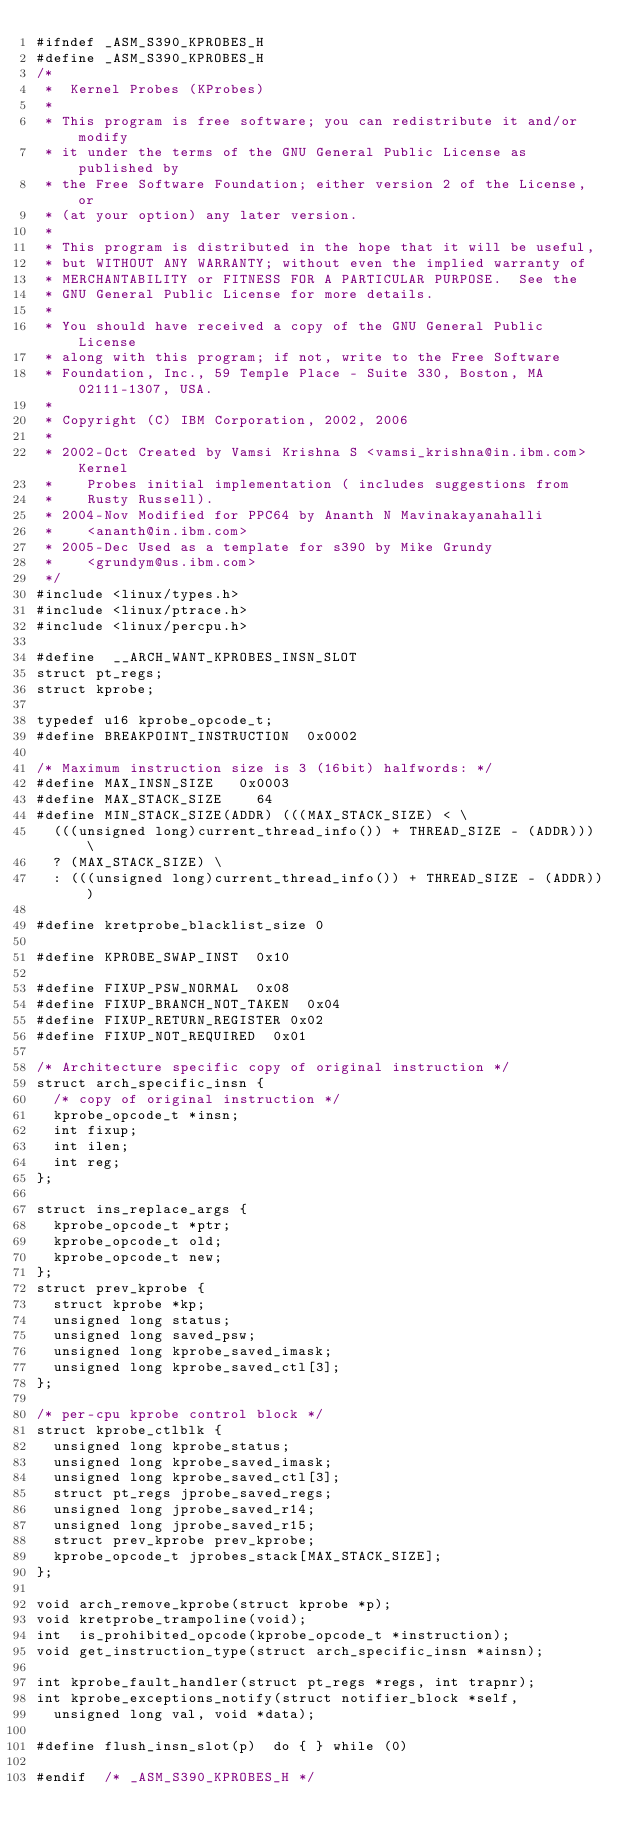<code> <loc_0><loc_0><loc_500><loc_500><_C_>#ifndef _ASM_S390_KPROBES_H
#define _ASM_S390_KPROBES_H
/*
 *  Kernel Probes (KProbes)
 *
 * This program is free software; you can redistribute it and/or modify
 * it under the terms of the GNU General Public License as published by
 * the Free Software Foundation; either version 2 of the License, or
 * (at your option) any later version.
 *
 * This program is distributed in the hope that it will be useful,
 * but WITHOUT ANY WARRANTY; without even the implied warranty of
 * MERCHANTABILITY or FITNESS FOR A PARTICULAR PURPOSE.  See the
 * GNU General Public License for more details.
 *
 * You should have received a copy of the GNU General Public License
 * along with this program; if not, write to the Free Software
 * Foundation, Inc., 59 Temple Place - Suite 330, Boston, MA 02111-1307, USA.
 *
 * Copyright (C) IBM Corporation, 2002, 2006
 *
 * 2002-Oct	Created by Vamsi Krishna S <vamsi_krishna@in.ibm.com> Kernel
 *		Probes initial implementation ( includes suggestions from
 *		Rusty Russell).
 * 2004-Nov	Modified for PPC64 by Ananth N Mavinakayanahalli
 *		<ananth@in.ibm.com>
 * 2005-Dec	Used as a template for s390 by Mike Grundy
 *		<grundym@us.ibm.com>
 */
#include <linux/types.h>
#include <linux/ptrace.h>
#include <linux/percpu.h>

#define  __ARCH_WANT_KPROBES_INSN_SLOT
struct pt_regs;
struct kprobe;

typedef u16 kprobe_opcode_t;
#define BREAKPOINT_INSTRUCTION	0x0002

/* Maximum instruction size is 3 (16bit) halfwords: */
#define MAX_INSN_SIZE		0x0003
#define MAX_STACK_SIZE		64
#define MIN_STACK_SIZE(ADDR) (((MAX_STACK_SIZE) < \
	(((unsigned long)current_thread_info()) + THREAD_SIZE - (ADDR))) \
	? (MAX_STACK_SIZE) \
	: (((unsigned long)current_thread_info()) + THREAD_SIZE - (ADDR)))

#define kretprobe_blacklist_size 0

#define KPROBE_SWAP_INST	0x10

#define FIXUP_PSW_NORMAL	0x08
#define FIXUP_BRANCH_NOT_TAKEN	0x04
#define FIXUP_RETURN_REGISTER	0x02
#define FIXUP_NOT_REQUIRED	0x01

/* Architecture specific copy of original instruction */
struct arch_specific_insn {
	/* copy of original instruction */
	kprobe_opcode_t *insn;
	int fixup;
	int ilen;
	int reg;
};

struct ins_replace_args {
	kprobe_opcode_t *ptr;
	kprobe_opcode_t old;
	kprobe_opcode_t new;
};
struct prev_kprobe {
	struct kprobe *kp;
	unsigned long status;
	unsigned long saved_psw;
	unsigned long kprobe_saved_imask;
	unsigned long kprobe_saved_ctl[3];
};

/* per-cpu kprobe control block */
struct kprobe_ctlblk {
	unsigned long kprobe_status;
	unsigned long kprobe_saved_imask;
	unsigned long kprobe_saved_ctl[3];
	struct pt_regs jprobe_saved_regs;
	unsigned long jprobe_saved_r14;
	unsigned long jprobe_saved_r15;
	struct prev_kprobe prev_kprobe;
	kprobe_opcode_t jprobes_stack[MAX_STACK_SIZE];
};

void arch_remove_kprobe(struct kprobe *p);
void kretprobe_trampoline(void);
int  is_prohibited_opcode(kprobe_opcode_t *instruction);
void get_instruction_type(struct arch_specific_insn *ainsn);

int kprobe_fault_handler(struct pt_regs *regs, int trapnr);
int kprobe_exceptions_notify(struct notifier_block *self,
	unsigned long val, void *data);

#define flush_insn_slot(p)	do { } while (0)

#endif	/* _ASM_S390_KPROBES_H */
</code> 